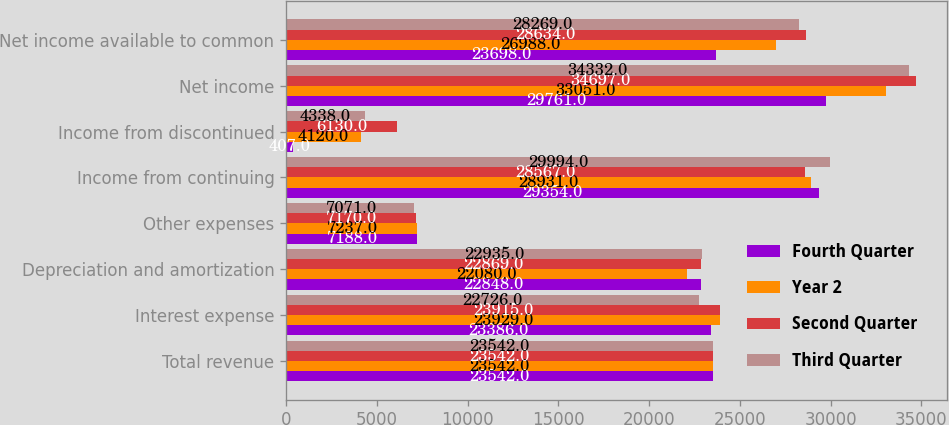Convert chart. <chart><loc_0><loc_0><loc_500><loc_500><stacked_bar_chart><ecel><fcel>Total revenue<fcel>Interest expense<fcel>Depreciation and amortization<fcel>Other expenses<fcel>Income from continuing<fcel>Income from discontinued<fcel>Net income<fcel>Net income available to common<nl><fcel>Fourth Quarter<fcel>23542<fcel>23386<fcel>22848<fcel>7188<fcel>29354<fcel>407<fcel>29761<fcel>23698<nl><fcel>Year 2<fcel>23542<fcel>23929<fcel>22080<fcel>7237<fcel>28931<fcel>4120<fcel>33051<fcel>26988<nl><fcel>Second Quarter<fcel>23542<fcel>23915<fcel>22869<fcel>7170<fcel>28567<fcel>6130<fcel>34697<fcel>28634<nl><fcel>Third Quarter<fcel>23542<fcel>22726<fcel>22935<fcel>7071<fcel>29994<fcel>4338<fcel>34332<fcel>28269<nl></chart> 